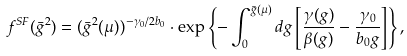<formula> <loc_0><loc_0><loc_500><loc_500>f ^ { S F } ( \bar { g } ^ { 2 } ) = ( \bar { g } ^ { 2 } ( \mu ) ) ^ { - \gamma _ { 0 } / 2 b _ { 0 } } \cdot \exp \left \{ - \int _ { 0 } ^ { \bar { g } ( \mu ) } d g \left [ \frac { \gamma ( g ) } { \beta ( g ) } - \frac { \gamma _ { 0 } } { b _ { 0 } g } \right ] \right \} ,</formula> 